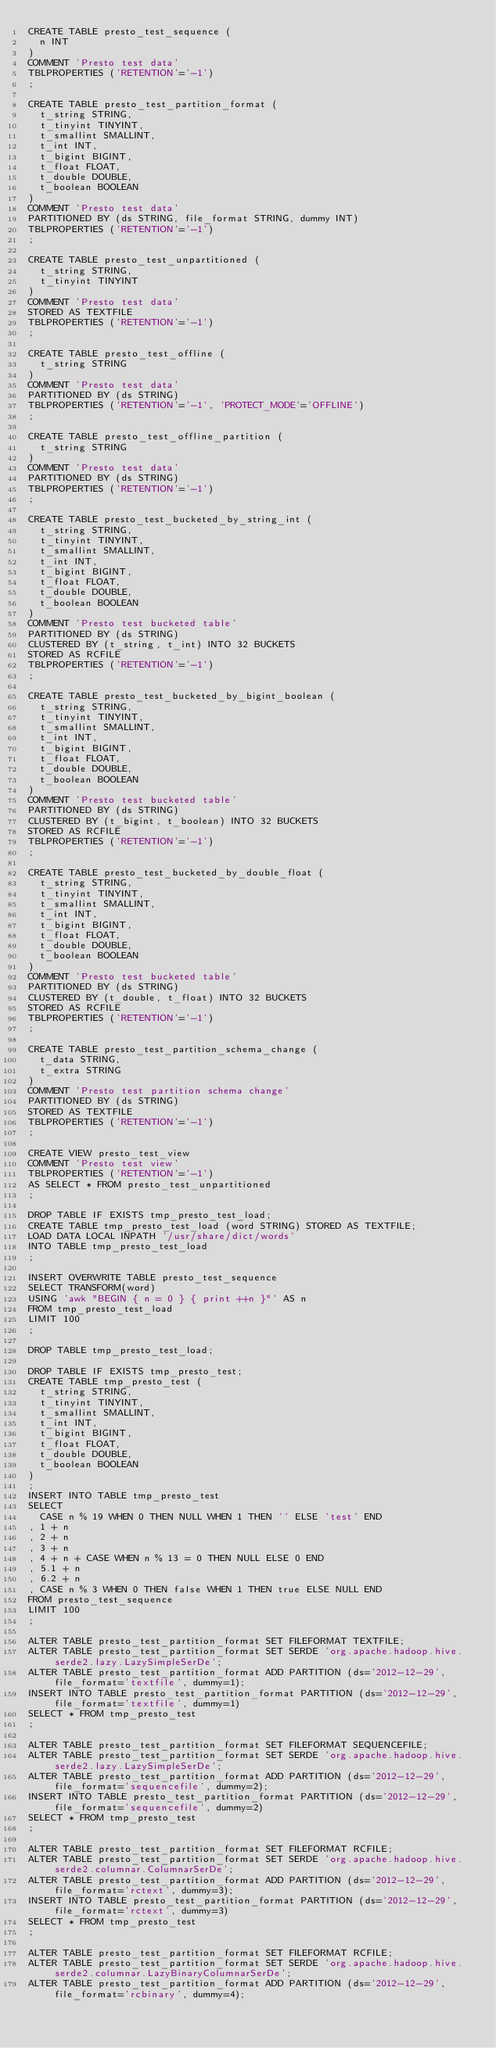<code> <loc_0><loc_0><loc_500><loc_500><_SQL_>CREATE TABLE presto_test_sequence (
  n INT
)
COMMENT 'Presto test data'
TBLPROPERTIES ('RETENTION'='-1')
;

CREATE TABLE presto_test_partition_format (
  t_string STRING,
  t_tinyint TINYINT,
  t_smallint SMALLINT,
  t_int INT,
  t_bigint BIGINT,
  t_float FLOAT,
  t_double DOUBLE,
  t_boolean BOOLEAN
)
COMMENT 'Presto test data'
PARTITIONED BY (ds STRING, file_format STRING, dummy INT)
TBLPROPERTIES ('RETENTION'='-1')
;

CREATE TABLE presto_test_unpartitioned (
  t_string STRING,
  t_tinyint TINYINT
)
COMMENT 'Presto test data'
STORED AS TEXTFILE
TBLPROPERTIES ('RETENTION'='-1')
;

CREATE TABLE presto_test_offline (
  t_string STRING
)
COMMENT 'Presto test data'
PARTITIONED BY (ds STRING)
TBLPROPERTIES ('RETENTION'='-1', 'PROTECT_MODE'='OFFLINE')
;

CREATE TABLE presto_test_offline_partition (
  t_string STRING
)
COMMENT 'Presto test data'
PARTITIONED BY (ds STRING)
TBLPROPERTIES ('RETENTION'='-1')
;

CREATE TABLE presto_test_bucketed_by_string_int (
  t_string STRING,
  t_tinyint TINYINT,
  t_smallint SMALLINT,
  t_int INT,
  t_bigint BIGINT,
  t_float FLOAT,
  t_double DOUBLE,
  t_boolean BOOLEAN
)
COMMENT 'Presto test bucketed table'
PARTITIONED BY (ds STRING)
CLUSTERED BY (t_string, t_int) INTO 32 BUCKETS
STORED AS RCFILE
TBLPROPERTIES ('RETENTION'='-1')
;

CREATE TABLE presto_test_bucketed_by_bigint_boolean (
  t_string STRING,
  t_tinyint TINYINT,
  t_smallint SMALLINT,
  t_int INT,
  t_bigint BIGINT,
  t_float FLOAT,
  t_double DOUBLE,
  t_boolean BOOLEAN
)
COMMENT 'Presto test bucketed table'
PARTITIONED BY (ds STRING)
CLUSTERED BY (t_bigint, t_boolean) INTO 32 BUCKETS
STORED AS RCFILE
TBLPROPERTIES ('RETENTION'='-1')
;

CREATE TABLE presto_test_bucketed_by_double_float (
  t_string STRING,
  t_tinyint TINYINT,
  t_smallint SMALLINT,
  t_int INT,
  t_bigint BIGINT,
  t_float FLOAT,
  t_double DOUBLE,
  t_boolean BOOLEAN
)
COMMENT 'Presto test bucketed table'
PARTITIONED BY (ds STRING)
CLUSTERED BY (t_double, t_float) INTO 32 BUCKETS
STORED AS RCFILE
TBLPROPERTIES ('RETENTION'='-1')
;

CREATE TABLE presto_test_partition_schema_change (
  t_data STRING,
  t_extra STRING
)
COMMENT 'Presto test partition schema change'
PARTITIONED BY (ds STRING)
STORED AS TEXTFILE
TBLPROPERTIES ('RETENTION'='-1')
;

CREATE VIEW presto_test_view
COMMENT 'Presto test view'
TBLPROPERTIES ('RETENTION'='-1')
AS SELECT * FROM presto_test_unpartitioned
;

DROP TABLE IF EXISTS tmp_presto_test_load;
CREATE TABLE tmp_presto_test_load (word STRING) STORED AS TEXTFILE;
LOAD DATA LOCAL INPATH '/usr/share/dict/words'
INTO TABLE tmp_presto_test_load
;

INSERT OVERWRITE TABLE presto_test_sequence
SELECT TRANSFORM(word)
USING 'awk "BEGIN { n = 0 } { print ++n }"' AS n
FROM tmp_presto_test_load
LIMIT 100
;

DROP TABLE tmp_presto_test_load;

DROP TABLE IF EXISTS tmp_presto_test;
CREATE TABLE tmp_presto_test (
  t_string STRING,
  t_tinyint TINYINT,
  t_smallint SMALLINT,
  t_int INT,
  t_bigint BIGINT,
  t_float FLOAT,
  t_double DOUBLE,
  t_boolean BOOLEAN
)
;
INSERT INTO TABLE tmp_presto_test
SELECT
  CASE n % 19 WHEN 0 THEN NULL WHEN 1 THEN '' ELSE 'test' END
, 1 + n
, 2 + n
, 3 + n
, 4 + n + CASE WHEN n % 13 = 0 THEN NULL ELSE 0 END
, 5.1 + n
, 6.2 + n
, CASE n % 3 WHEN 0 THEN false WHEN 1 THEN true ELSE NULL END
FROM presto_test_sequence
LIMIT 100
;

ALTER TABLE presto_test_partition_format SET FILEFORMAT TEXTFILE;
ALTER TABLE presto_test_partition_format SET SERDE 'org.apache.hadoop.hive.serde2.lazy.LazySimpleSerDe';
ALTER TABLE presto_test_partition_format ADD PARTITION (ds='2012-12-29', file_format='textfile', dummy=1);
INSERT INTO TABLE presto_test_partition_format PARTITION (ds='2012-12-29', file_format='textfile', dummy=1)
SELECT * FROM tmp_presto_test
;

ALTER TABLE presto_test_partition_format SET FILEFORMAT SEQUENCEFILE;
ALTER TABLE presto_test_partition_format SET SERDE 'org.apache.hadoop.hive.serde2.lazy.LazySimpleSerDe';
ALTER TABLE presto_test_partition_format ADD PARTITION (ds='2012-12-29', file_format='sequencefile', dummy=2);
INSERT INTO TABLE presto_test_partition_format PARTITION (ds='2012-12-29', file_format='sequencefile', dummy=2)
SELECT * FROM tmp_presto_test
;

ALTER TABLE presto_test_partition_format SET FILEFORMAT RCFILE;
ALTER TABLE presto_test_partition_format SET SERDE 'org.apache.hadoop.hive.serde2.columnar.ColumnarSerDe';
ALTER TABLE presto_test_partition_format ADD PARTITION (ds='2012-12-29', file_format='rctext', dummy=3);
INSERT INTO TABLE presto_test_partition_format PARTITION (ds='2012-12-29', file_format='rctext', dummy=3)
SELECT * FROM tmp_presto_test
;

ALTER TABLE presto_test_partition_format SET FILEFORMAT RCFILE;
ALTER TABLE presto_test_partition_format SET SERDE 'org.apache.hadoop.hive.serde2.columnar.LazyBinaryColumnarSerDe';
ALTER TABLE presto_test_partition_format ADD PARTITION (ds='2012-12-29', file_format='rcbinary', dummy=4);</code> 